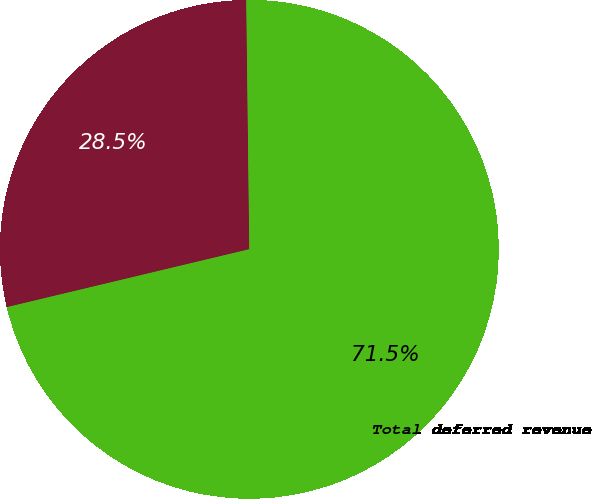<chart> <loc_0><loc_0><loc_500><loc_500><pie_chart><fcel>Other net<fcel>Total deferred revenue<nl><fcel>28.54%<fcel>71.46%<nl></chart> 